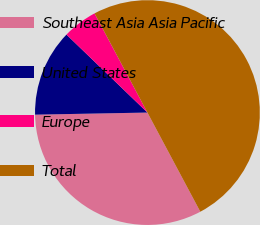<chart> <loc_0><loc_0><loc_500><loc_500><pie_chart><fcel>Southeast Asia Asia Pacific<fcel>United States<fcel>Europe<fcel>Total<nl><fcel>32.5%<fcel>12.5%<fcel>5.0%<fcel>50.0%<nl></chart> 